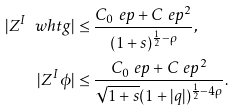Convert formula to latex. <formula><loc_0><loc_0><loc_500><loc_500>| Z ^ { I } \ w h t g | & \leq \frac { C _ { 0 } \ e p + C \ e p ^ { 2 } } { ( 1 + s ) ^ { \frac { 1 } { 2 } - \rho } } , \\ | Z ^ { I } \phi | & \leq \frac { C _ { 0 } \ e p + C \ e p ^ { 2 } } { \sqrt { 1 + s } ( 1 + | q | ) ^ { \frac { 1 } { 2 } - 4 \rho } } .</formula> 